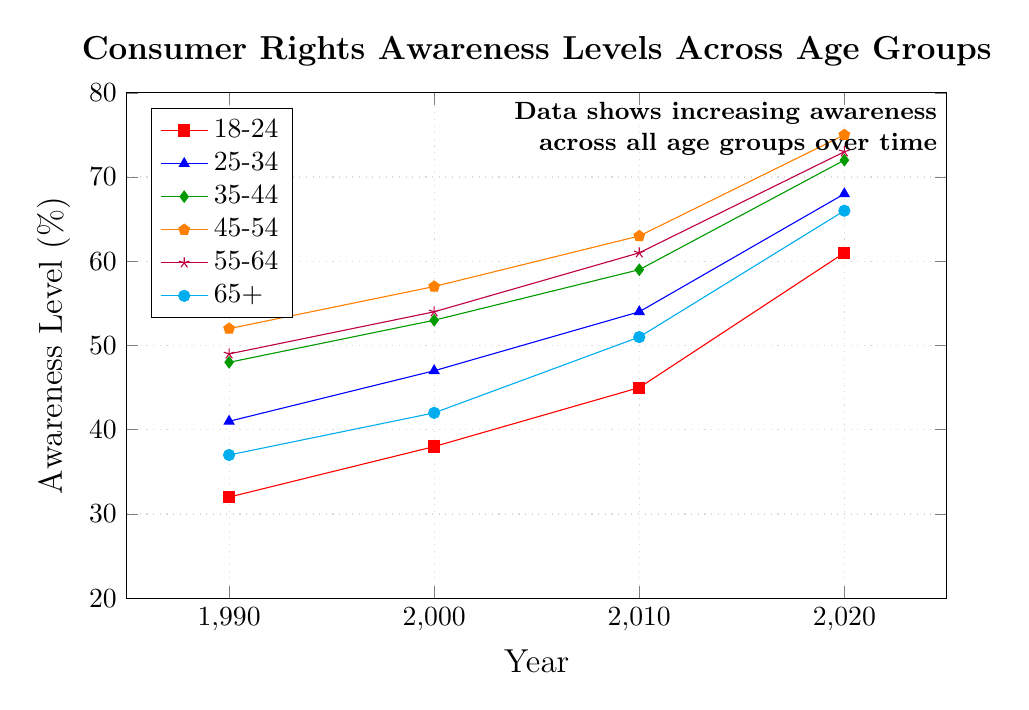What is the awareness level of the 18-24 age group in 2010? Locate the 18-24 age group on the legend (marked with red squares) and find the corresponding point in 2010 on the x-axis, which aligns with 45% on the y-axis.
Answer: 45% Which age group had the highest awareness level in 2020? Compare the awareness levels of all age groups for the year 2020 on the x-axis. The 45-54 age group (marked with orange pentagons) has the highest value of 75%.
Answer: 45-54 How much did the awareness level increase for the 55-64 age group from 1990 to 2020? Identify the 55-64 age group (marked with purple stars) and compare the values for 1990 and 2020, which are 49% and 73%, respectively. The increase is 73 - 49 = 24%.
Answer: 24% What is the average awareness level of the 35-44 age group over all the years shown? Locate the 35-44 age group (marked with green diamonds) and sum the awareness levels for all years: 48 + 53 + 59 + 72 = 232. Divide by the number of years (4) to get the average: 232 / 4 = 58%.
Answer: 58% Which age group had the smallest increase in awareness level between 1990 and 2020? Calculate the increase for each age group from 1990 to 2020. The increases are:
- 18-24 (61 - 32) = 29%
- 25-34 (68 - 41) = 27%
- 35-44 (72 - 48) = 24%
- 45-54 (75 - 52) = 23%
- 55-64 (73 - 49) = 24%
- 65+ (66 - 37) = 29%
The 45-54 group has the smallest increase of 23%.
Answer: 45-54 By how much did the awareness level of the 25-34 age group surpass the 18-24 age group in 2020? Identify the 2020 values for the 25-34 (68%) and 18-24 (61%) age groups. Subtract 61 from 68 to find the difference: 68 - 61 = 7%.
Answer: 7% What is the trend for the awareness levels in all age groups over the years? Examine the slopes of all lines in the chart. All age groups show an upward trend with awareness levels increasing over time from 1990 to 2020.
Answer: Increasing What is the median awareness level for the 65+ age group over the years? Collect the awareness levels for the 65+ age group (37, 42, 51, 66) and order them: 37, 42, 51, 66. The median is the average of the two middle numbers: (42 + 51) / 2 = 46.5%.
Answer: 46.5% Is the awareness level of the 45-54 age group always higher than the 18-24 age group? Compare the awareness levels of the 45-54 and 18-24 age groups for each year: 1990 (52 > 32), 2000 (57 > 38), 2010 (63 > 45), 2020 (75 > 61). The 45-54 age group is always higher.
Answer: Yes 